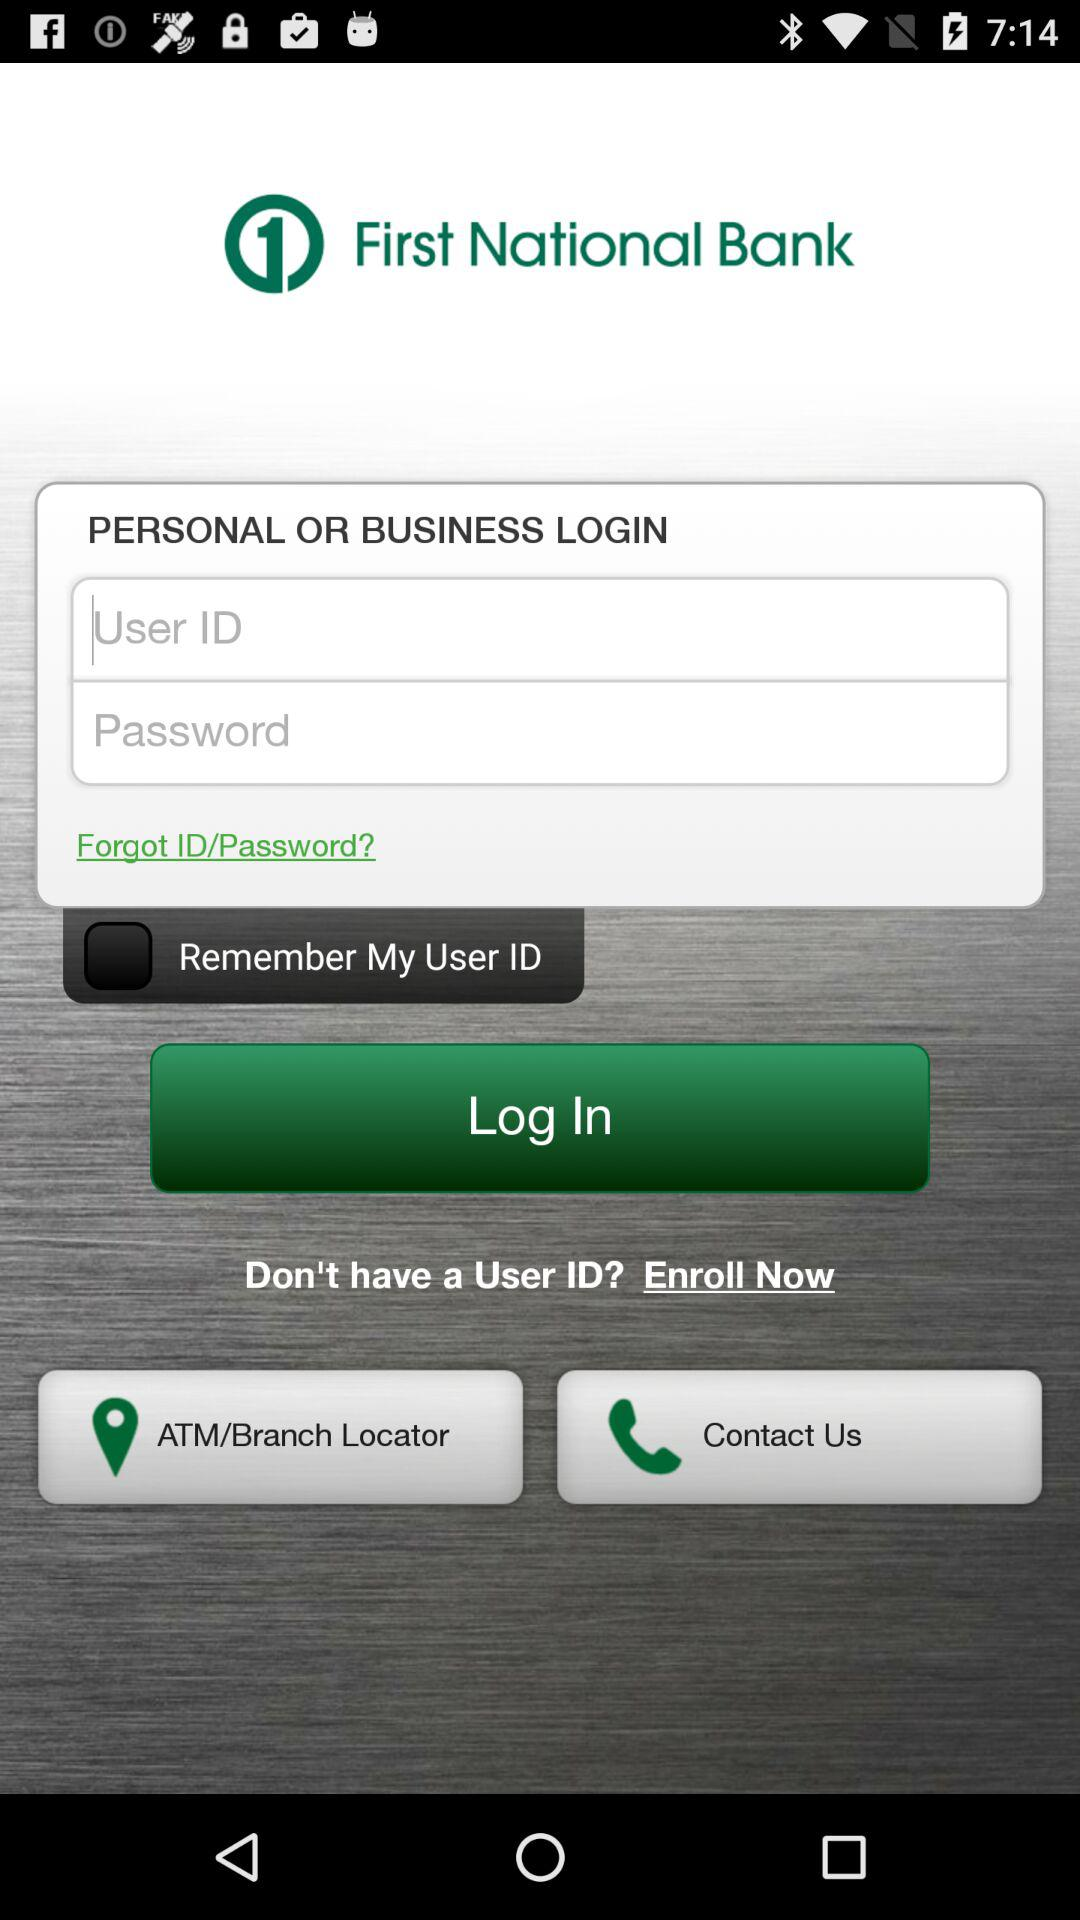What is the name of the application? The name of the application is "First National Bank". 